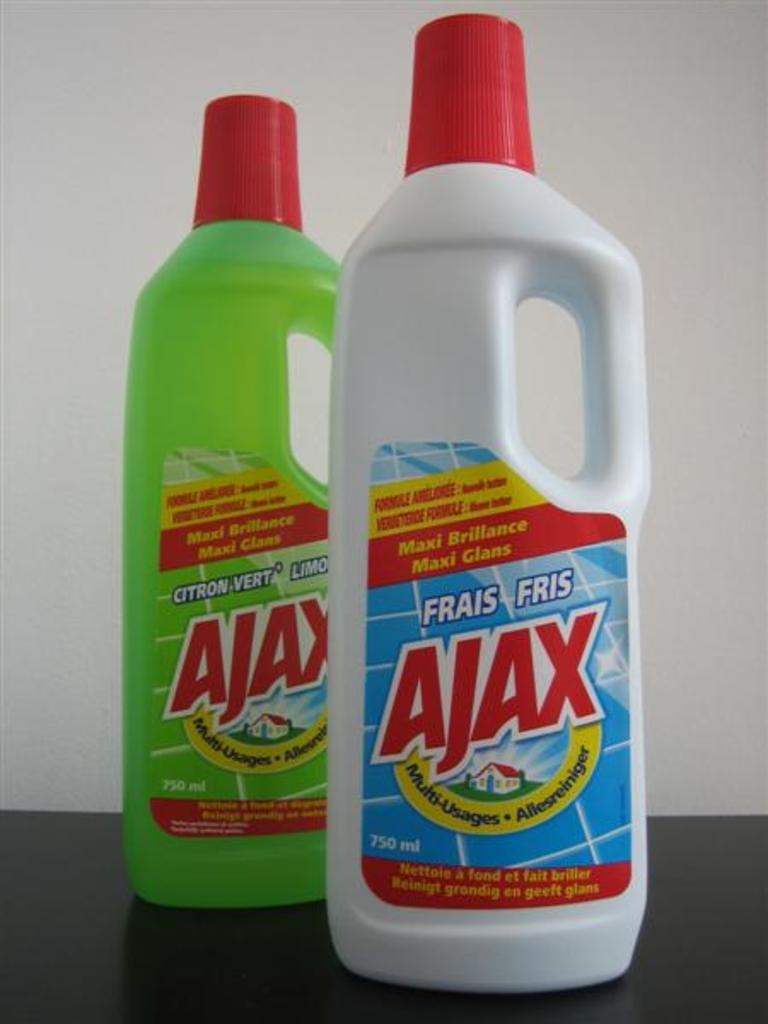How many bottles can be seen in the image? There are two bottles in the image. What colors are the bottles? One bottle is green in color, and the other bottle is white in color. What is visible in the background of the image? There is a wall in the background of the image. What type of punishment is being administered to the bottles in the image? There is no punishment being administered to the bottles in the image; they are simply bottles sitting on a surface. 